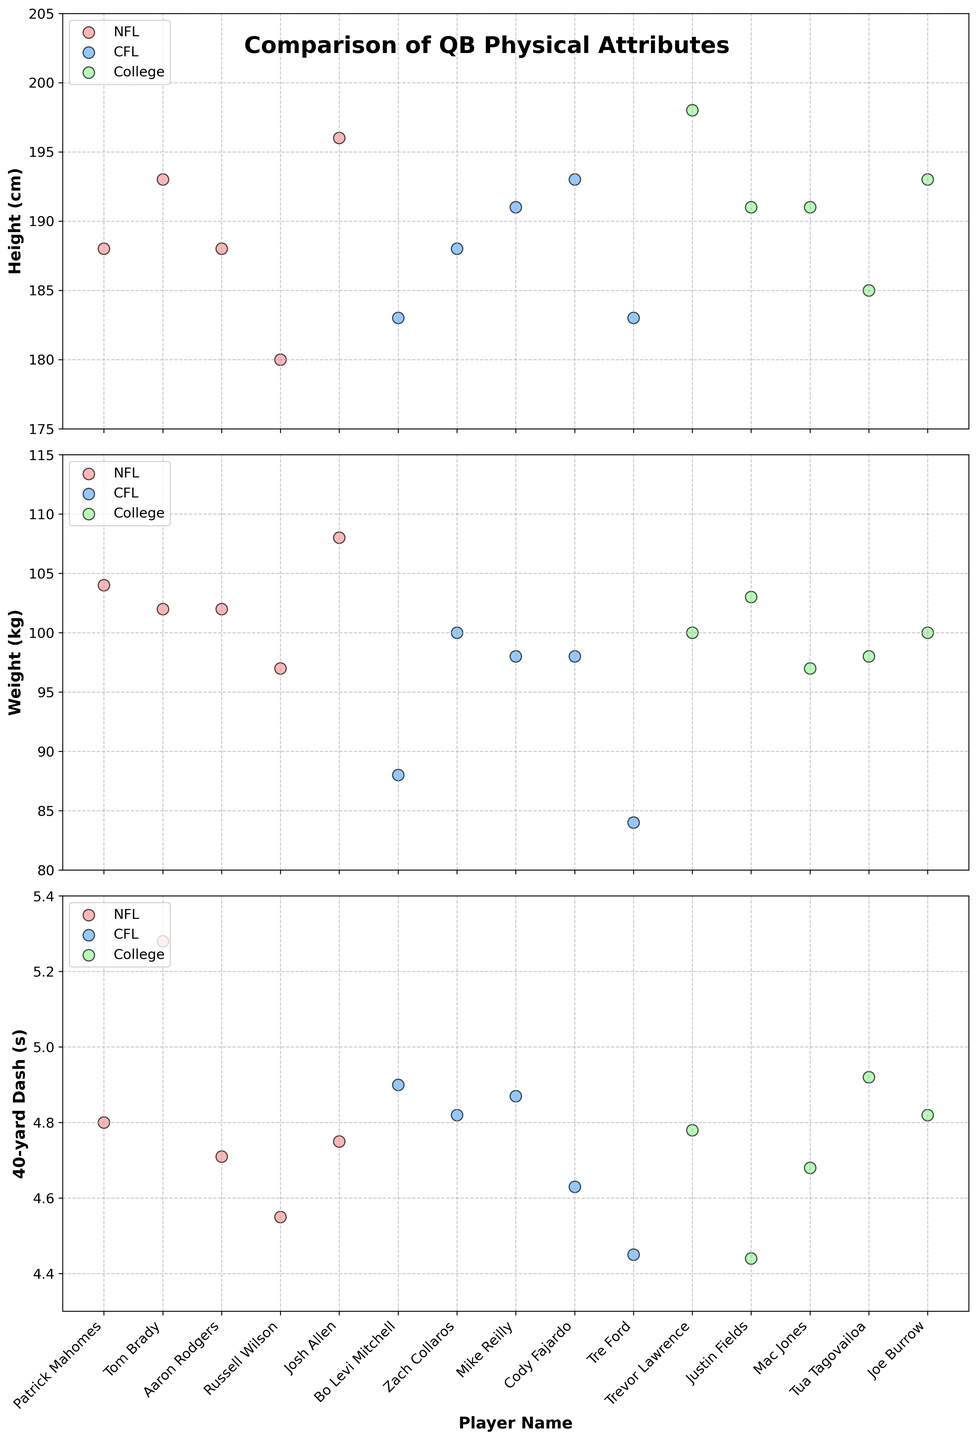Which league has the tallest quarterback? To determine the tallest quarterback, look at the heights on the height subplot. Compare the heights of quarterbacks across the NFL, CFL, and College levels. The tallest quarterback is Trevor Lawrence from the College league at 198 cm.
Answer: College Which quarterback has the fastest 40-yard dash time? To find the quarterback with the fastest 40-yard dash time, look at the times on the 40-yard dash subplot. The faster times are represented by lower values. Tre Ford from the CFL has the fastest time at 4.45 seconds.
Answer: Tre Ford Is there any NFL quarterback taller than 193 cm? Examine the height subplot and look at the NFL quarterbacks' heights. None of the NFL quarterbacks listed exceed 193 cm.
Answer: No Who is heavier, Josh Allen or Trevor Lawrence? Check the weight subplot and compare the weights of Josh Allen and Trevor Lawrence. Josh Allen weighs 108 kg while Trevor Lawrence weighs 100 kg.
Answer: Josh Allen Which player has the shortest height among all quarterbacks? Look at the height subplot and identify the shortest height among all quarterbacks. Russell Wilson from the NFL at 180 cm is the shortest.
Answer: Russell Wilson Amongst NFL quarterbacks, who has the lightest weight? On the weight subplot, compare the weights of all NFL quarterbacks. Russell Wilson has the lightest weight at 97 kg.
Answer: Russell Wilson Who has a faster 40-yard dash time, Justin Fields or Tre Ford? Refer to the 40-yard dash subplot and compare the times for Justin Fields and Tre Ford. Tre Ford's 4.45 seconds is faster than Justin Fields' 4.44 seconds.
Answer: Tre Ford What is the average weight of CFL quarterbacks? To calculate the average weight, sum the weights of all CFL quarterbacks and divide by the number of CFL quarterbacks. The weights are 88, 100, 98, 98, and 84 kg. So, (88 + 100 + 98 + 98 + 84) / 5 = 93.6 kg.
Answer: 93.6 kg Which league has the most quarterbacks taller than 190 cm? Look at the height subplot and count the number of quarterbacks taller than 190 cm in each league. NFL has 2 (Tom Brady, Josh Allen), CFL has 2 (Mike Reilly, Cody Fajardo), and College has 2 (Trevor Lawrence, Mac Jones).
Answer: Tie between NFL, CFL, and College Which quarterback weighs the most in the College league? On the weight subplot, look at the weights of the College quarterbacks. Justin Fields has the heaviest weight at 103 kg.
Answer: Justin Fields 